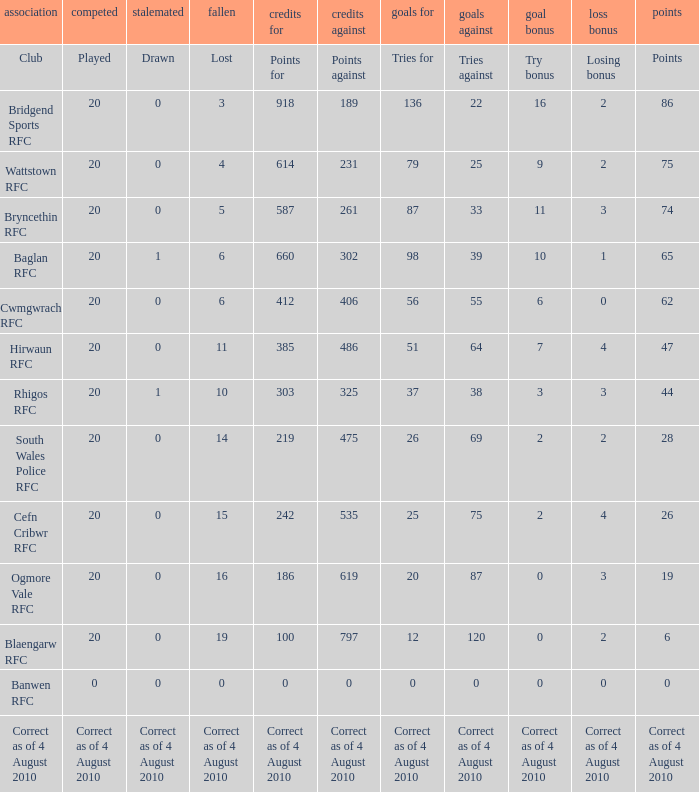Give me the full table as a dictionary. {'header': ['association', 'competed', 'stalemated', 'fallen', 'credits for', 'credits against', 'goals for', 'goals against', 'goal bonus', 'loss bonus', 'points'], 'rows': [['Club', 'Played', 'Drawn', 'Lost', 'Points for', 'Points against', 'Tries for', 'Tries against', 'Try bonus', 'Losing bonus', 'Points'], ['Bridgend Sports RFC', '20', '0', '3', '918', '189', '136', '22', '16', '2', '86'], ['Wattstown RFC', '20', '0', '4', '614', '231', '79', '25', '9', '2', '75'], ['Bryncethin RFC', '20', '0', '5', '587', '261', '87', '33', '11', '3', '74'], ['Baglan RFC', '20', '1', '6', '660', '302', '98', '39', '10', '1', '65'], ['Cwmgwrach RFC', '20', '0', '6', '412', '406', '56', '55', '6', '0', '62'], ['Hirwaun RFC', '20', '0', '11', '385', '486', '51', '64', '7', '4', '47'], ['Rhigos RFC', '20', '1', '10', '303', '325', '37', '38', '3', '3', '44'], ['South Wales Police RFC', '20', '0', '14', '219', '475', '26', '69', '2', '2', '28'], ['Cefn Cribwr RFC', '20', '0', '15', '242', '535', '25', '75', '2', '4', '26'], ['Ogmore Vale RFC', '20', '0', '16', '186', '619', '20', '87', '0', '3', '19'], ['Blaengarw RFC', '20', '0', '19', '100', '797', '12', '120', '0', '2', '6'], ['Banwen RFC', '0', '0', '0', '0', '0', '0', '0', '0', '0', '0'], ['Correct as of 4 August 2010', 'Correct as of 4 August 2010', 'Correct as of 4 August 2010', 'Correct as of 4 August 2010', 'Correct as of 4 August 2010', 'Correct as of 4 August 2010', 'Correct as of 4 August 2010', 'Correct as of 4 August 2010', 'Correct as of 4 August 2010', 'Correct as of 4 August 2010', 'Correct as of 4 August 2010']]} What is the tries fow when losing bonus is losing bonus? Tries for. 